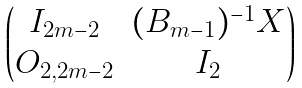Convert formula to latex. <formula><loc_0><loc_0><loc_500><loc_500>\begin{pmatrix} I _ { 2 m - 2 } & ( B _ { m - 1 } ) ^ { - 1 } X \\ O _ { 2 , 2 m - 2 } & I _ { 2 } \end{pmatrix}</formula> 